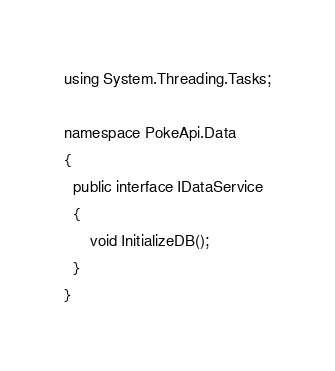<code> <loc_0><loc_0><loc_500><loc_500><_C#_>using System.Threading.Tasks;

namespace PokeApi.Data
{
  public interface IDataService
  {
      void InitializeDB();
  }
}</code> 